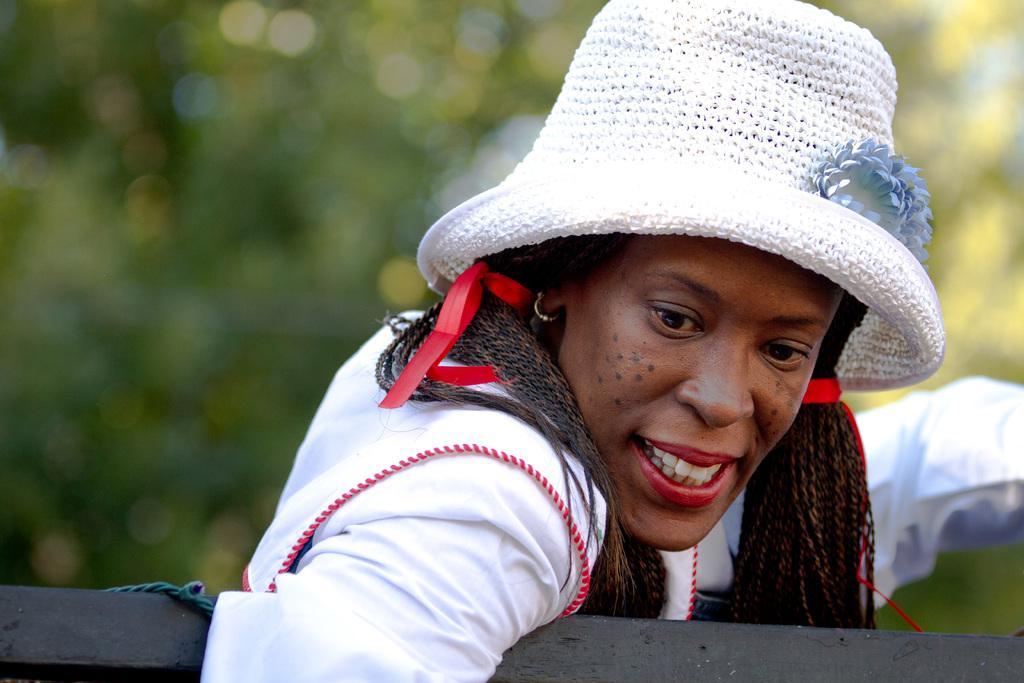In one or two sentences, can you explain what this image depicts? In this image I can see the person wearing the white and red color dress and also hat. In-front of the person I can see the rod. In the background I can see the trees but it is blurry. 